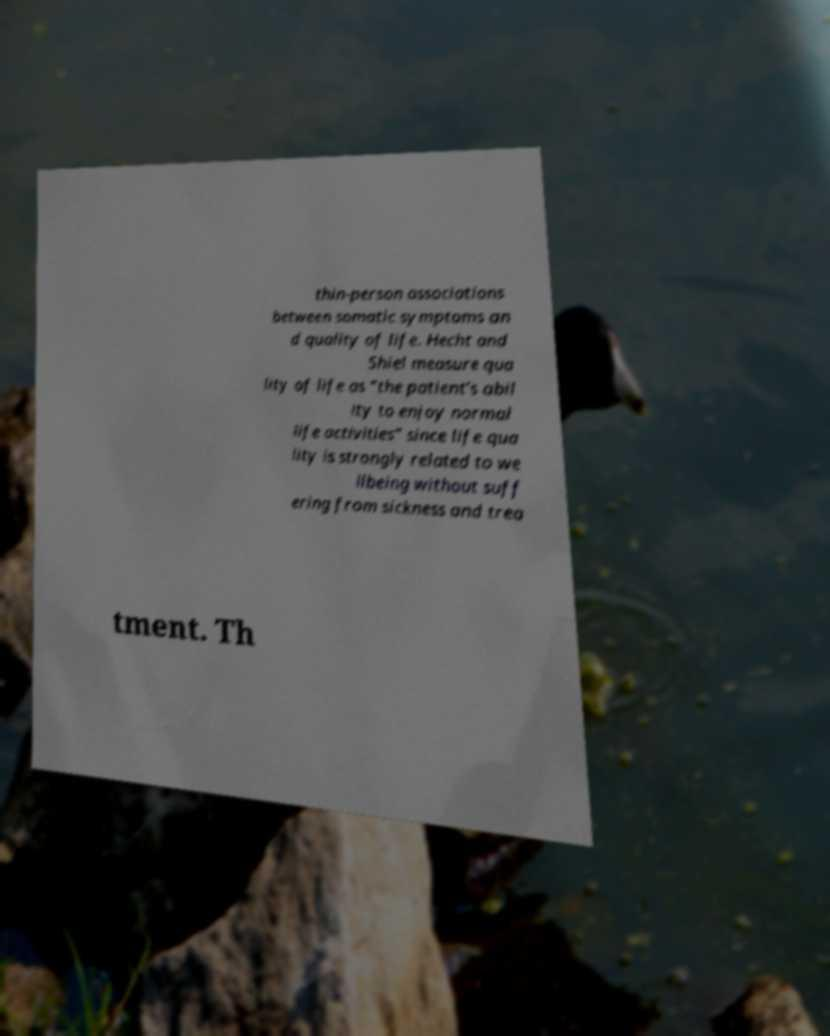Could you assist in decoding the text presented in this image and type it out clearly? thin-person associations between somatic symptoms an d quality of life. Hecht and Shiel measure qua lity of life as “the patient’s abil ity to enjoy normal life activities” since life qua lity is strongly related to we llbeing without suff ering from sickness and trea tment. Th 